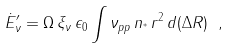<formula> <loc_0><loc_0><loc_500><loc_500>\dot { E } ^ { \prime } _ { \nu } = \Omega \, \xi _ { \nu } \, \epsilon _ { 0 } \int \nu _ { p p } \, n _ { ^ { * } } \, r ^ { 2 } \, d ( \Delta R ) \ ,</formula> 